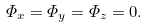<formula> <loc_0><loc_0><loc_500><loc_500>\varPhi _ { x } = \varPhi _ { y } = \varPhi _ { z } = 0 .</formula> 